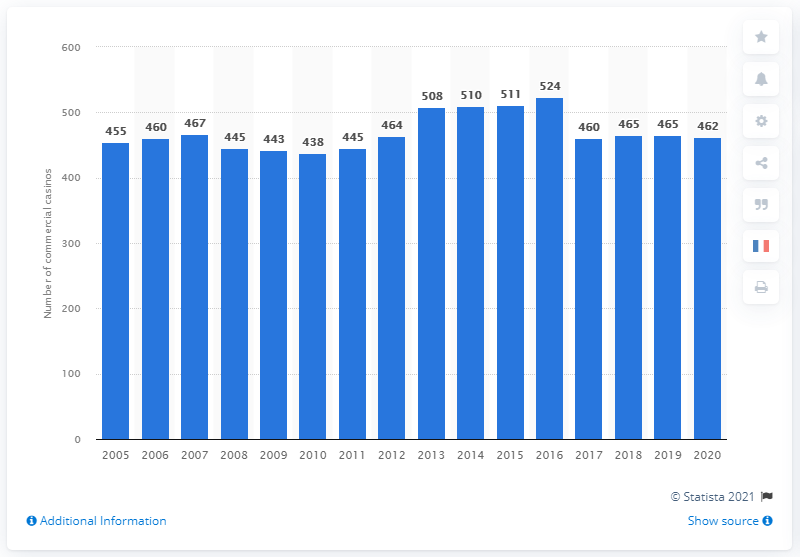Give some essential details in this illustration. The number of commercial casinos began to increase in the year 2010. In 2020, there were 462 commercial casinos operating in the United States. 